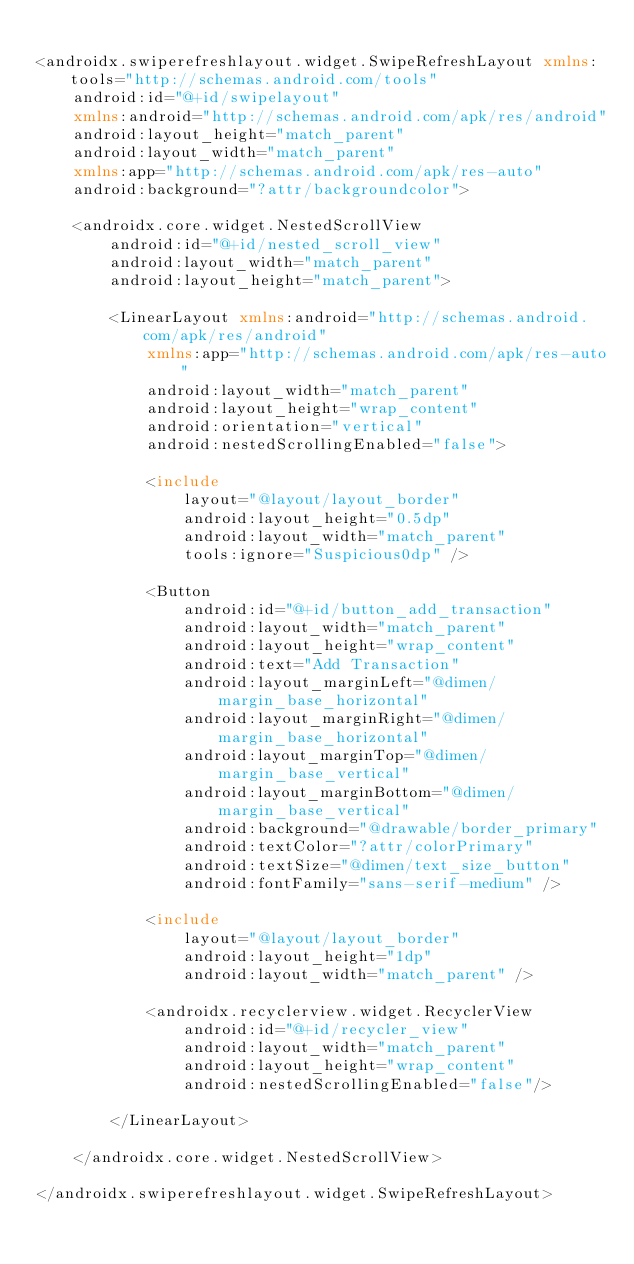<code> <loc_0><loc_0><loc_500><loc_500><_XML_>
<androidx.swiperefreshlayout.widget.SwipeRefreshLayout xmlns:tools="http://schemas.android.com/tools"
    android:id="@+id/swipelayout"
    xmlns:android="http://schemas.android.com/apk/res/android"
    android:layout_height="match_parent"
    android:layout_width="match_parent"
    xmlns:app="http://schemas.android.com/apk/res-auto"
    android:background="?attr/backgroundcolor">

    <androidx.core.widget.NestedScrollView
        android:id="@+id/nested_scroll_view"
        android:layout_width="match_parent"
        android:layout_height="match_parent">

        <LinearLayout xmlns:android="http://schemas.android.com/apk/res/android"
            xmlns:app="http://schemas.android.com/apk/res-auto"
            android:layout_width="match_parent"
            android:layout_height="wrap_content"
            android:orientation="vertical"
            android:nestedScrollingEnabled="false">

            <include
                layout="@layout/layout_border"
                android:layout_height="0.5dp"
                android:layout_width="match_parent"
                tools:ignore="Suspicious0dp" />

            <Button
                android:id="@+id/button_add_transaction"
                android:layout_width="match_parent"
                android:layout_height="wrap_content"
                android:text="Add Transaction"
                android:layout_marginLeft="@dimen/margin_base_horizontal"
                android:layout_marginRight="@dimen/margin_base_horizontal"
                android:layout_marginTop="@dimen/margin_base_vertical"
                android:layout_marginBottom="@dimen/margin_base_vertical"
                android:background="@drawable/border_primary"
                android:textColor="?attr/colorPrimary"
                android:textSize="@dimen/text_size_button"
                android:fontFamily="sans-serif-medium" />

            <include
                layout="@layout/layout_border"
                android:layout_height="1dp"
                android:layout_width="match_parent" />

            <androidx.recyclerview.widget.RecyclerView
                android:id="@+id/recycler_view"
                android:layout_width="match_parent"
                android:layout_height="wrap_content"
                android:nestedScrollingEnabled="false"/>

        </LinearLayout>

    </androidx.core.widget.NestedScrollView>

</androidx.swiperefreshlayout.widget.SwipeRefreshLayout></code> 